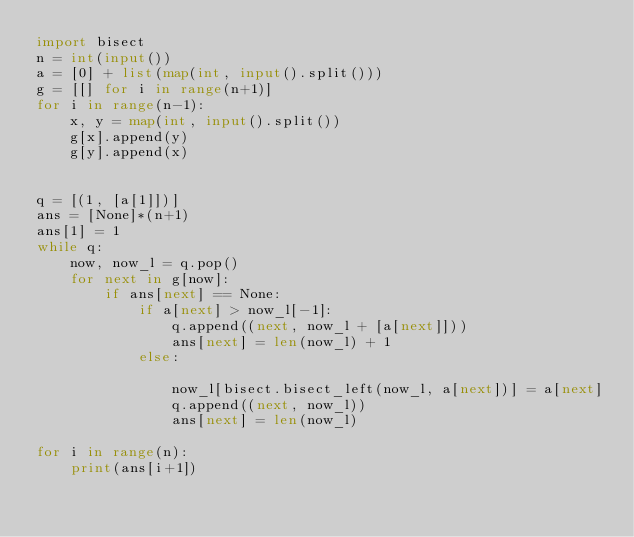Convert code to text. <code><loc_0><loc_0><loc_500><loc_500><_Python_>import bisect
n = int(input())
a = [0] + list(map(int, input().split()))
g = [[] for i in range(n+1)]
for i in range(n-1):
    x, y = map(int, input().split())
    g[x].append(y)
    g[y].append(x)


q = [(1, [a[1]])]
ans = [None]*(n+1)
ans[1] = 1
while q:
    now, now_l = q.pop()
    for next in g[now]:
        if ans[next] == None:
            if a[next] > now_l[-1]:
                q.append((next, now_l + [a[next]]))
                ans[next] = len(now_l) + 1
            else:

                now_l[bisect.bisect_left(now_l, a[next])] = a[next]
                q.append((next, now_l))
                ans[next] = len(now_l)

for i in range(n):
    print(ans[i+1])
</code> 